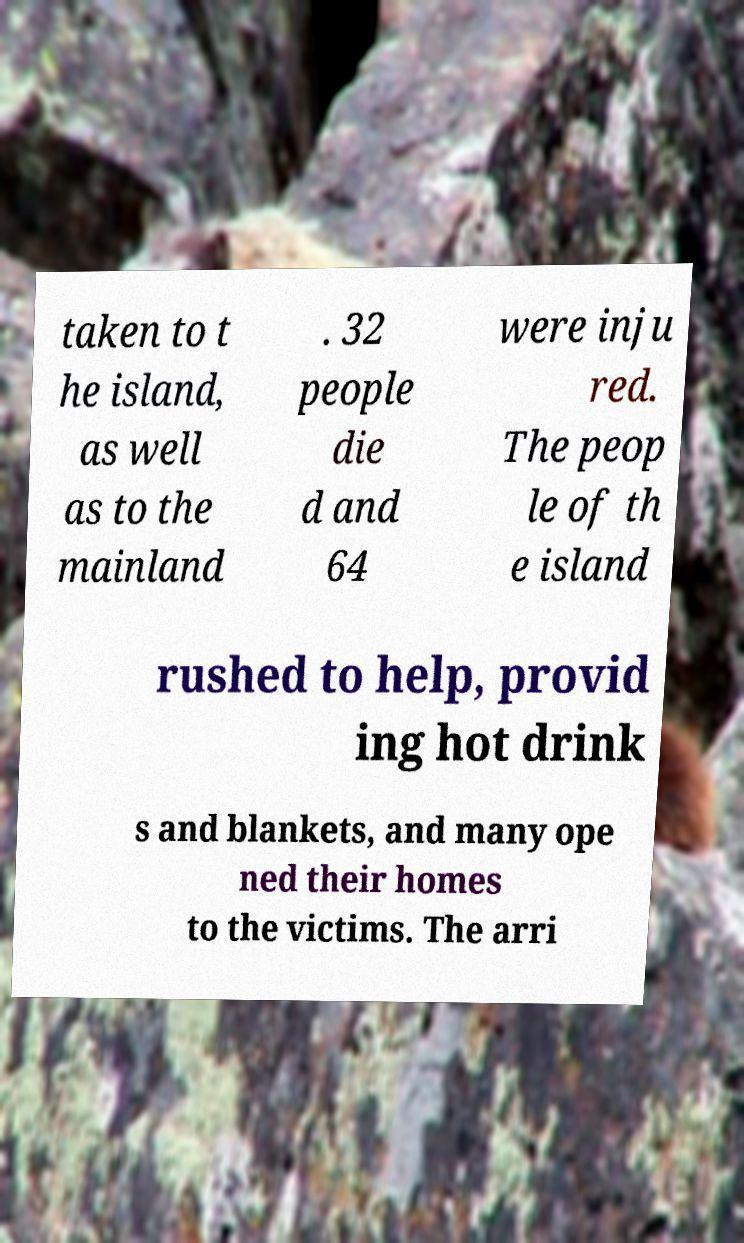Could you extract and type out the text from this image? taken to t he island, as well as to the mainland . 32 people die d and 64 were inju red. The peop le of th e island rushed to help, provid ing hot drink s and blankets, and many ope ned their homes to the victims. The arri 